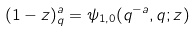Convert formula to latex. <formula><loc_0><loc_0><loc_500><loc_500>( 1 - z ) _ { q } ^ { a } = \psi _ { 1 , 0 } ( q ^ { - a } , q ; z )</formula> 